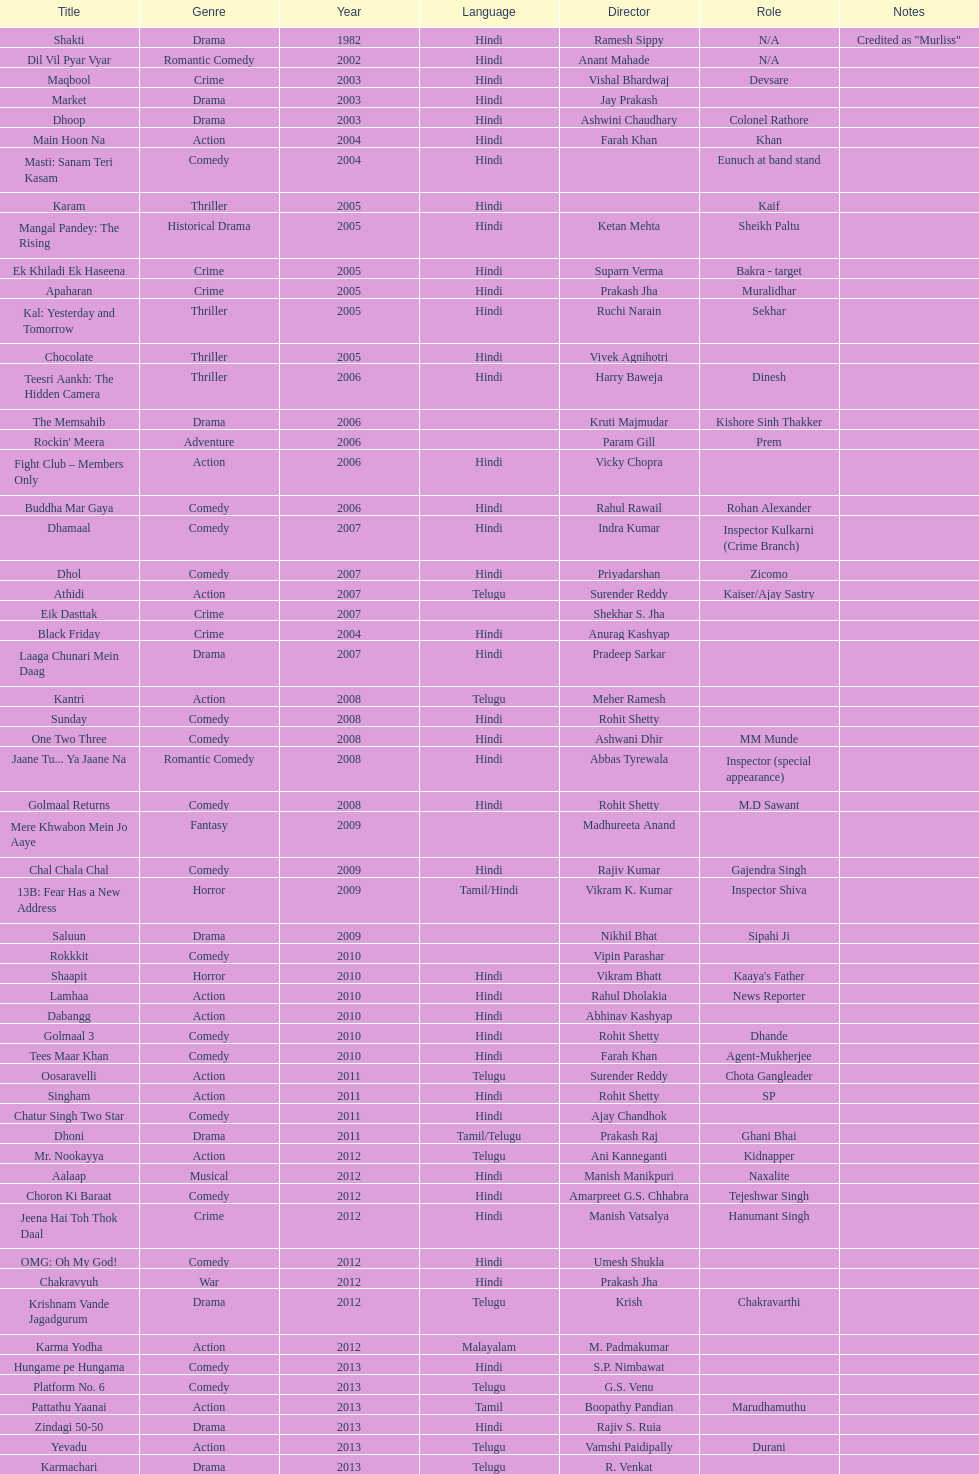What was the last malayalam film this actor starred in? Karma Yodha. 